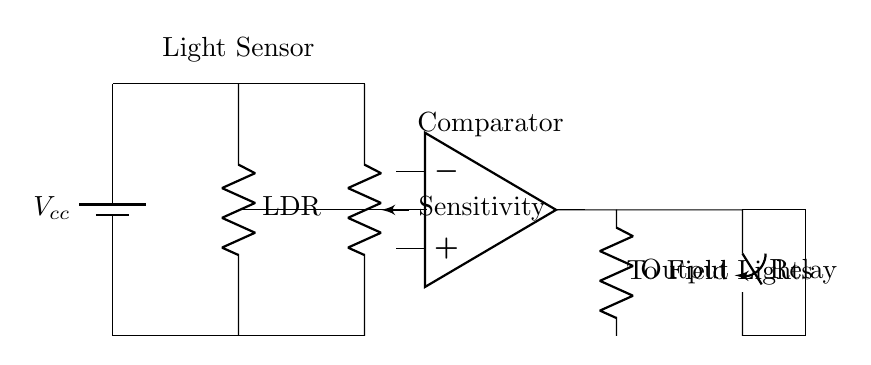What is the primary function of the LDR in this circuit? The Light Dependent Resistor (LDR) detects light levels and changes its resistance accordingly, which influences the output voltage seen by the operational amplifier.
Answer: Light detection What component controls the field lights based on the sensor's output? The relay acts as a switch that gets activated by the output from the operational amplifier to turn on the field lights when light levels are low.
Answer: Relay How many resistors are present in the circuit? There are two resistors: the LDR and the potentiometer for sensitivity adjustment, which adjust how the circuit responds to light conditions.
Answer: Two What type of amplifier is used in the circuit? The operational amplifier used in this circuit is termed a comparator, which compares the voltage from the LDR to a reference voltage for decision-making.
Answer: Comparator What would happen if the light level increases significantly? With an increase in light levels, the resistance of the LDR decreases, resulting in a lower output voltage from the operational amplifier, which would cause the relay to open and turn off the field lights.
Answer: Lights turn off What is the purpose of the potentiometer in this circuit? The potentiometer adjusts the circuit's sensitivity, allowing users to set a threshold that determines when the field lights should turn on based on light conditions.
Answer: Sensitivity adjustment In which part of the circuit is the voltage supplied? The voltage is supplied by the battery, which connects to the LDR and potentiometer, providing the necessary power for the operation of the circuit.
Answer: Battery 